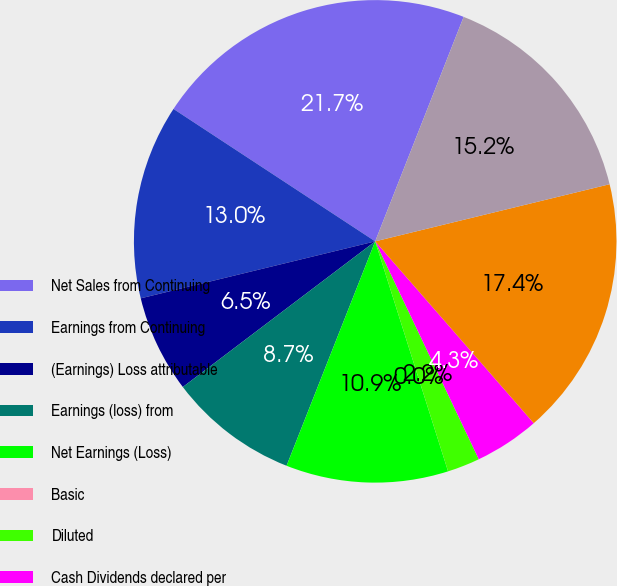Convert chart to OTSL. <chart><loc_0><loc_0><loc_500><loc_500><pie_chart><fcel>Net Sales from Continuing<fcel>Earnings from Continuing<fcel>(Earnings) Loss attributable<fcel>Earnings (loss) from<fcel>Net Earnings (Loss)<fcel>Basic<fcel>Diluted<fcel>Cash Dividends declared per<fcel>Total Assets<fcel>Long-term Debt including<nl><fcel>21.73%<fcel>13.04%<fcel>6.52%<fcel>8.7%<fcel>10.87%<fcel>0.0%<fcel>2.18%<fcel>4.35%<fcel>17.39%<fcel>15.22%<nl></chart> 